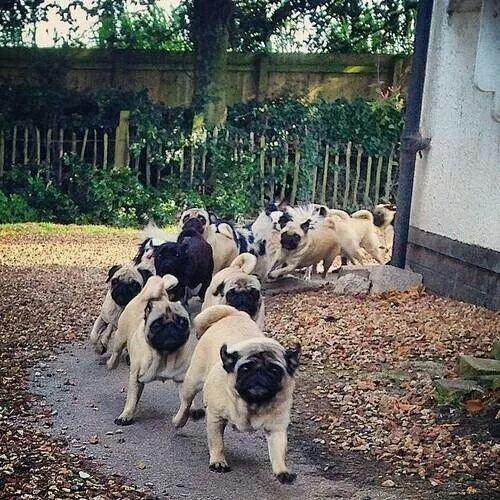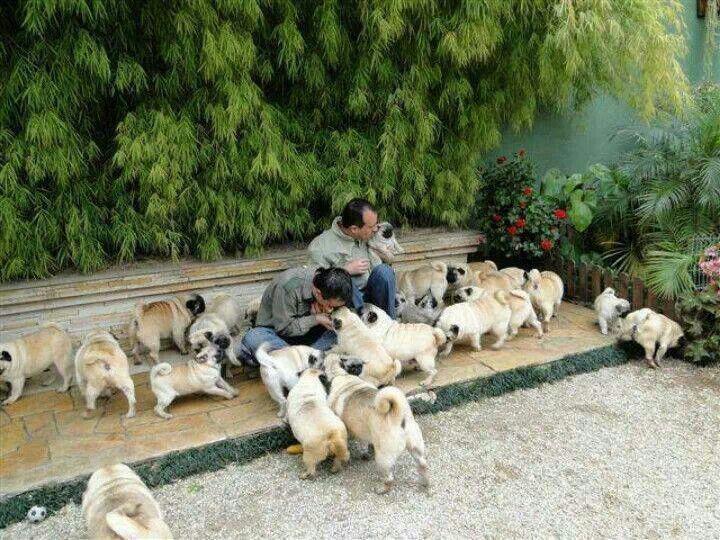The first image is the image on the left, the second image is the image on the right. For the images displayed, is the sentence "A person is standing in one of the images." factually correct? Answer yes or no. No. 